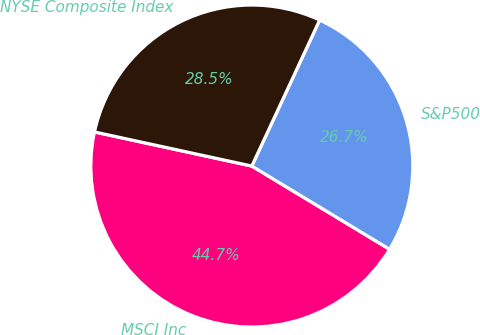Convert chart to OTSL. <chart><loc_0><loc_0><loc_500><loc_500><pie_chart><fcel>MSCI Inc<fcel>S&P500<fcel>NYSE Composite Index<nl><fcel>44.75%<fcel>26.73%<fcel>28.53%<nl></chart> 